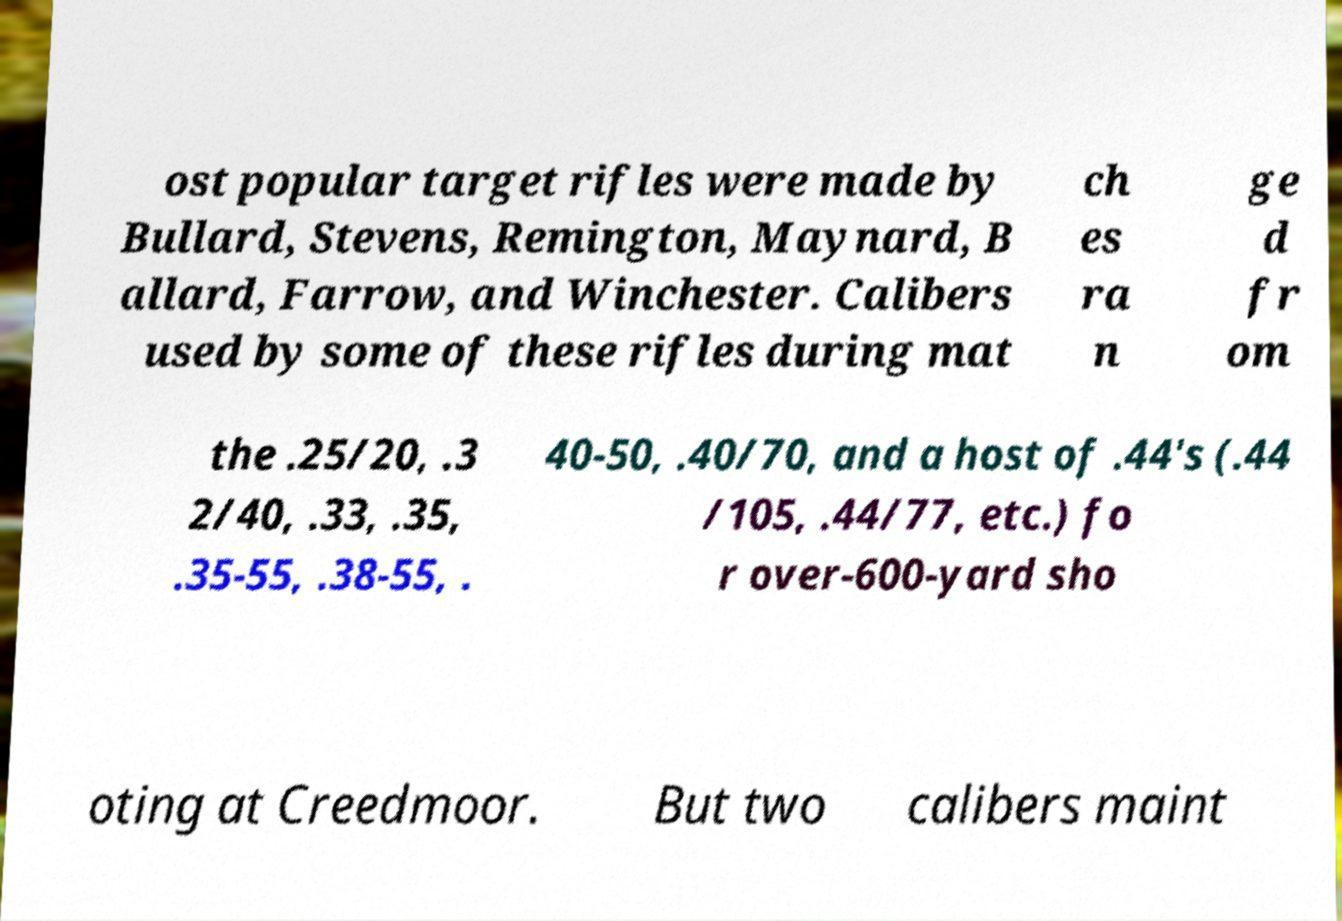Could you assist in decoding the text presented in this image and type it out clearly? ost popular target rifles were made by Bullard, Stevens, Remington, Maynard, B allard, Farrow, and Winchester. Calibers used by some of these rifles during mat ch es ra n ge d fr om the .25/20, .3 2/40, .33, .35, .35-55, .38-55, . 40-50, .40/70, and a host of .44's (.44 /105, .44/77, etc.) fo r over-600-yard sho oting at Creedmoor. But two calibers maint 